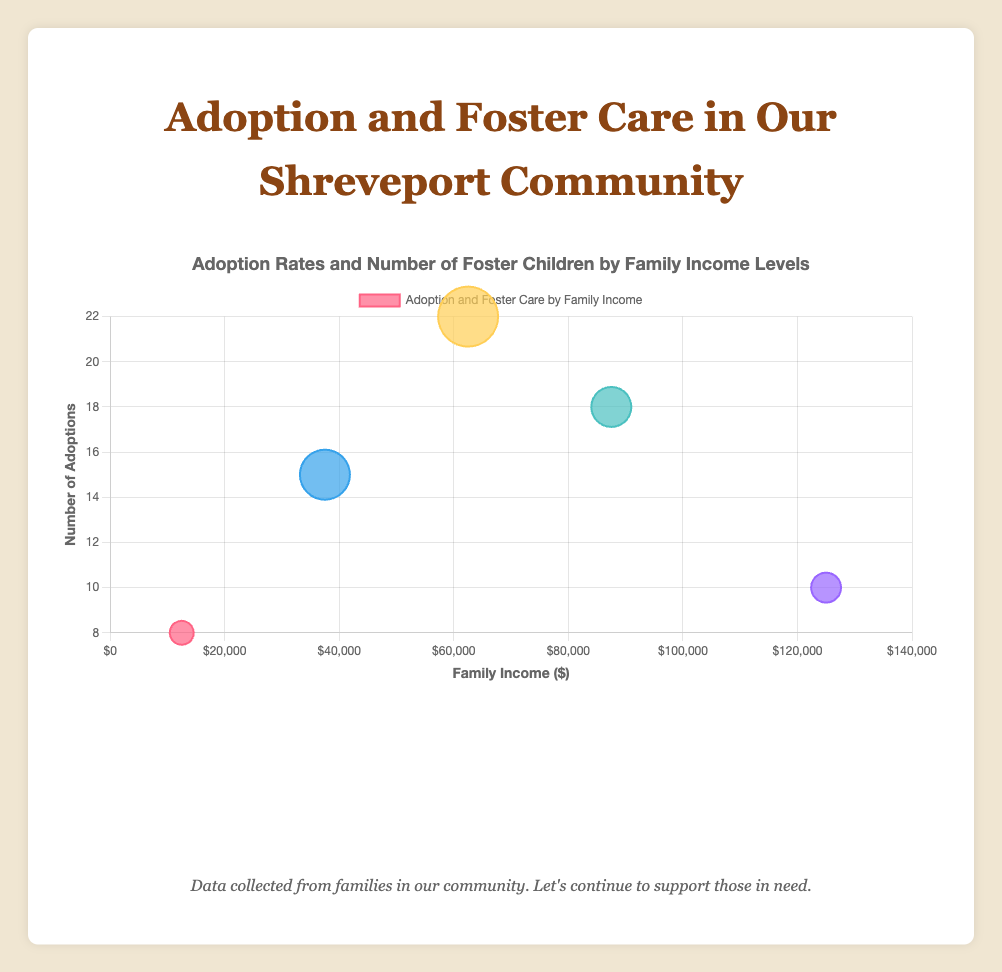What is the title of the chart? The title of the chart is displayed prominently at the top. It is "Adoption Rates and Number of Foster Children by Family Income Levels."
Answer: Adoption Rates and Number of Foster Children by Family Income Levels Which income level has the highest number of adoptions? Looking at the y-axis and corresponding data points, the income level with the highest number of adoptions is $50,000 - $75,000 with 22 adoptions.
Answer: $50,000 - $75,000 How many foster children are associated with families earning between $25,000 to $50,000? According to the size of the bubble and the tooltip information, families in the $25,000 - $50,000 income level have 25 foster children.
Answer: 25 What is the income level with the least number of adoptions? By examining the data points on the y-axis, the families earning Below $25,000 have the least number of adoptions, which is 8.
Answer: Below $25,000 Compare the number of foster children in the $75,000 - $100,000 income level to those in the Above $100,000 level. To compare, we look at the bubble size representing the number of foster children. $75,000 - $100,000 has 20 foster children, while Above $100,000 has 15 foster children. So, $75,000 - $100,000 has more foster children.
Answer: $75,000 - $100,000 What is the sum of adoptions for the income levels Above $100,000 and Below $25,000? The number of adoptions for Above $100,000 is 10 and for Below $25,000 is 8. Adding these together gives: 10 + 8 = 18.
Answer: 18 How many families are represented in the $50,000 - $75,000 income group? The families in this income level as per the data are ["Family I", "Family J", "Family K", "Family L"]. Counting these gives 4 families.
Answer: 4 Which income level has the largest number of foster children? Examining the size of the bubbles, the $50,000 - $75,000 income level has the largest number of foster children with 30.
Answer: $50,000 - $75,000 What is the difference in the number of adoptions between the income levels $25,000 - $50,000 and $75,000 - $100,000? Looking at the y-axis, $25,000 - $50,000 has 15 adoptions and $75,000 - $100,000 has 18 adoptions. The difference is calculated as 18 - 15 = 3.
Answer: 3 Which income level has more adoptions: Below $25,000 or Above $100,000? Checking the y-axis data points, Below $25,000 has 8 adoptions and Above $100,000 has 10 adoptions. So, Above $100,000 has more adoptions.
Answer: Above $100,000 